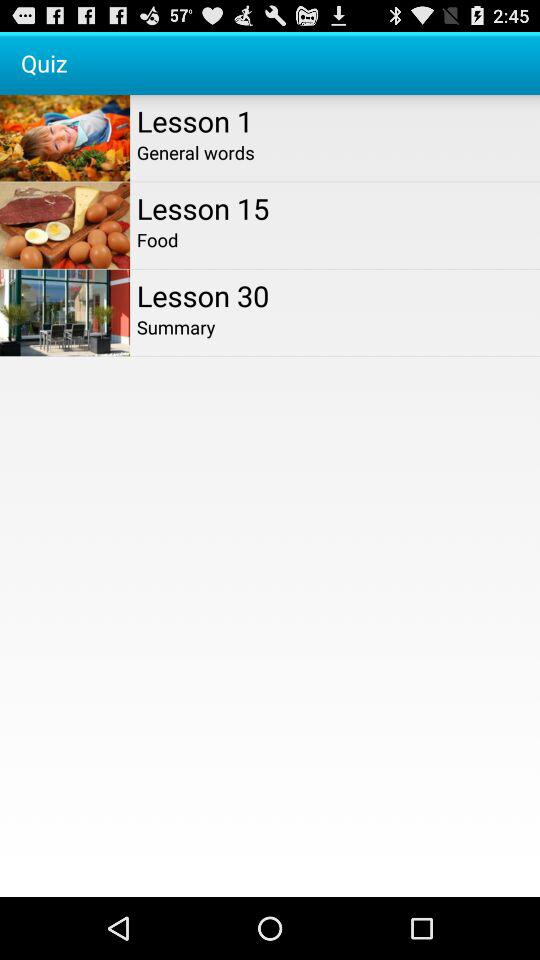Which lesson's name is "General words"? The lesson number is 1. 